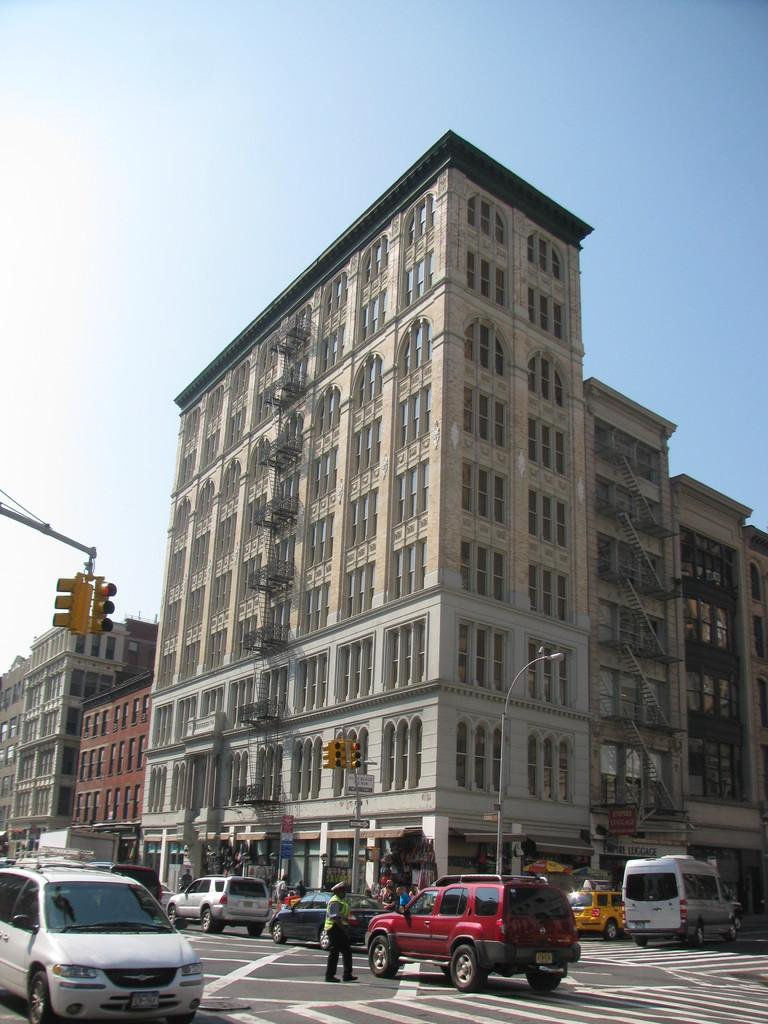What type of structures can be seen in the image? There are buildings in the image. What helps regulate traffic in the image? There are traffic signals in the image. Can you identify any living beings in the image? Yes, there are people visible in the image. What is moving on the road in the image? There are vehicles on the road in the image. What is visible at the top of the image? The sky is visible at the top of the image. What type of clouds can be seen in the image? There are no clouds visible in the image; only the sky is visible at the top. Can you tell me how many members are on the team in the image? There is no team present in the image; it features buildings, traffic signals, people, vehicles, and the sky. 